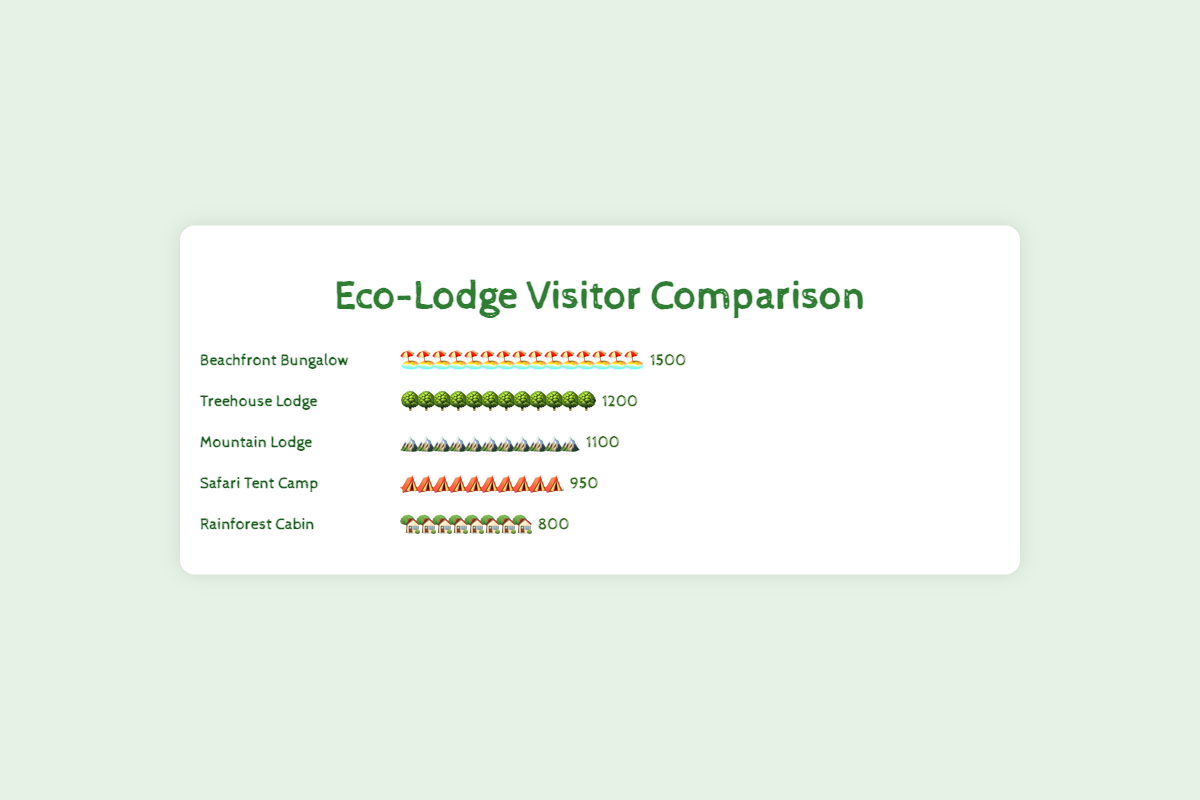Which eco-lodge type has the highest number of visitors? By observing the lengths of the icon sequences representing visitors, the Beachfront Bungalow has the longest, denoting it has the highest number of visitors.
Answer: Beachfront Bungalow How many visitors does the Safari Tent Camp have? Each tent icon represents approx. 95 visitors as there are 10 tent icons followed by the visitor count "950".
Answer: 950 Which eco-lodge type has the least number of visitors? Observing the shortest icon sequence, the Rainforest Cabin has the least number of visitors with only 8 cabin icons denoting "800".
Answer: Rainforest Cabin What is the total number of visitors for all the eco-lodges combined? Summing the visitor numbers from each eco-lodge type: 1200 (Treehouse Lodge) + 950 (Safari Tent Camp) + 800 (Rainforest Cabin) + 1500 (Beachfront Bungalow) + 1100 (Mountain Lodge) = 5550.
Answer: 5550 By how many visitors does the Beachfront Bungalow exceed the Mountain Lodge? The number of Beachfront Bungalow visitors is 1500 and Mountain Lodge visitors is 1100; the difference is 1500 - 1100 = 400.
Answer: 400 How many more visitors does the Treehouse Lodge have compared to the Rainforest Cabin? Comparing their visitor counts, 1200 (Treehouse Lodge) - 800 (Rainforest Cabin) = 400 more for Treehouse Lodge.
Answer: 400 What is the average number of visitors per eco-lodge type? Summing all visitors (5550) and dividing by the number of lodge types (5): 5550 / 5 = 1110.
Answer: 1110 Which eco-lodge types have more than 1000 visitors? Observing numbers greater than 1000 are Treehouse Lodge (1200), Beachfront Bungalow (1500), and Mountain Lodge (1100).
Answer: Treehouse Lodge, Beachfront Bungalow, Mountain Lodge How many visitors do the Treehouse Lodge and Safari Tent Camp have combined? Adding their visitor numbers: 1200 (Treehouse Lodge) + 950 (Safari Tent Camp) = 2150.
Answer: 2150 